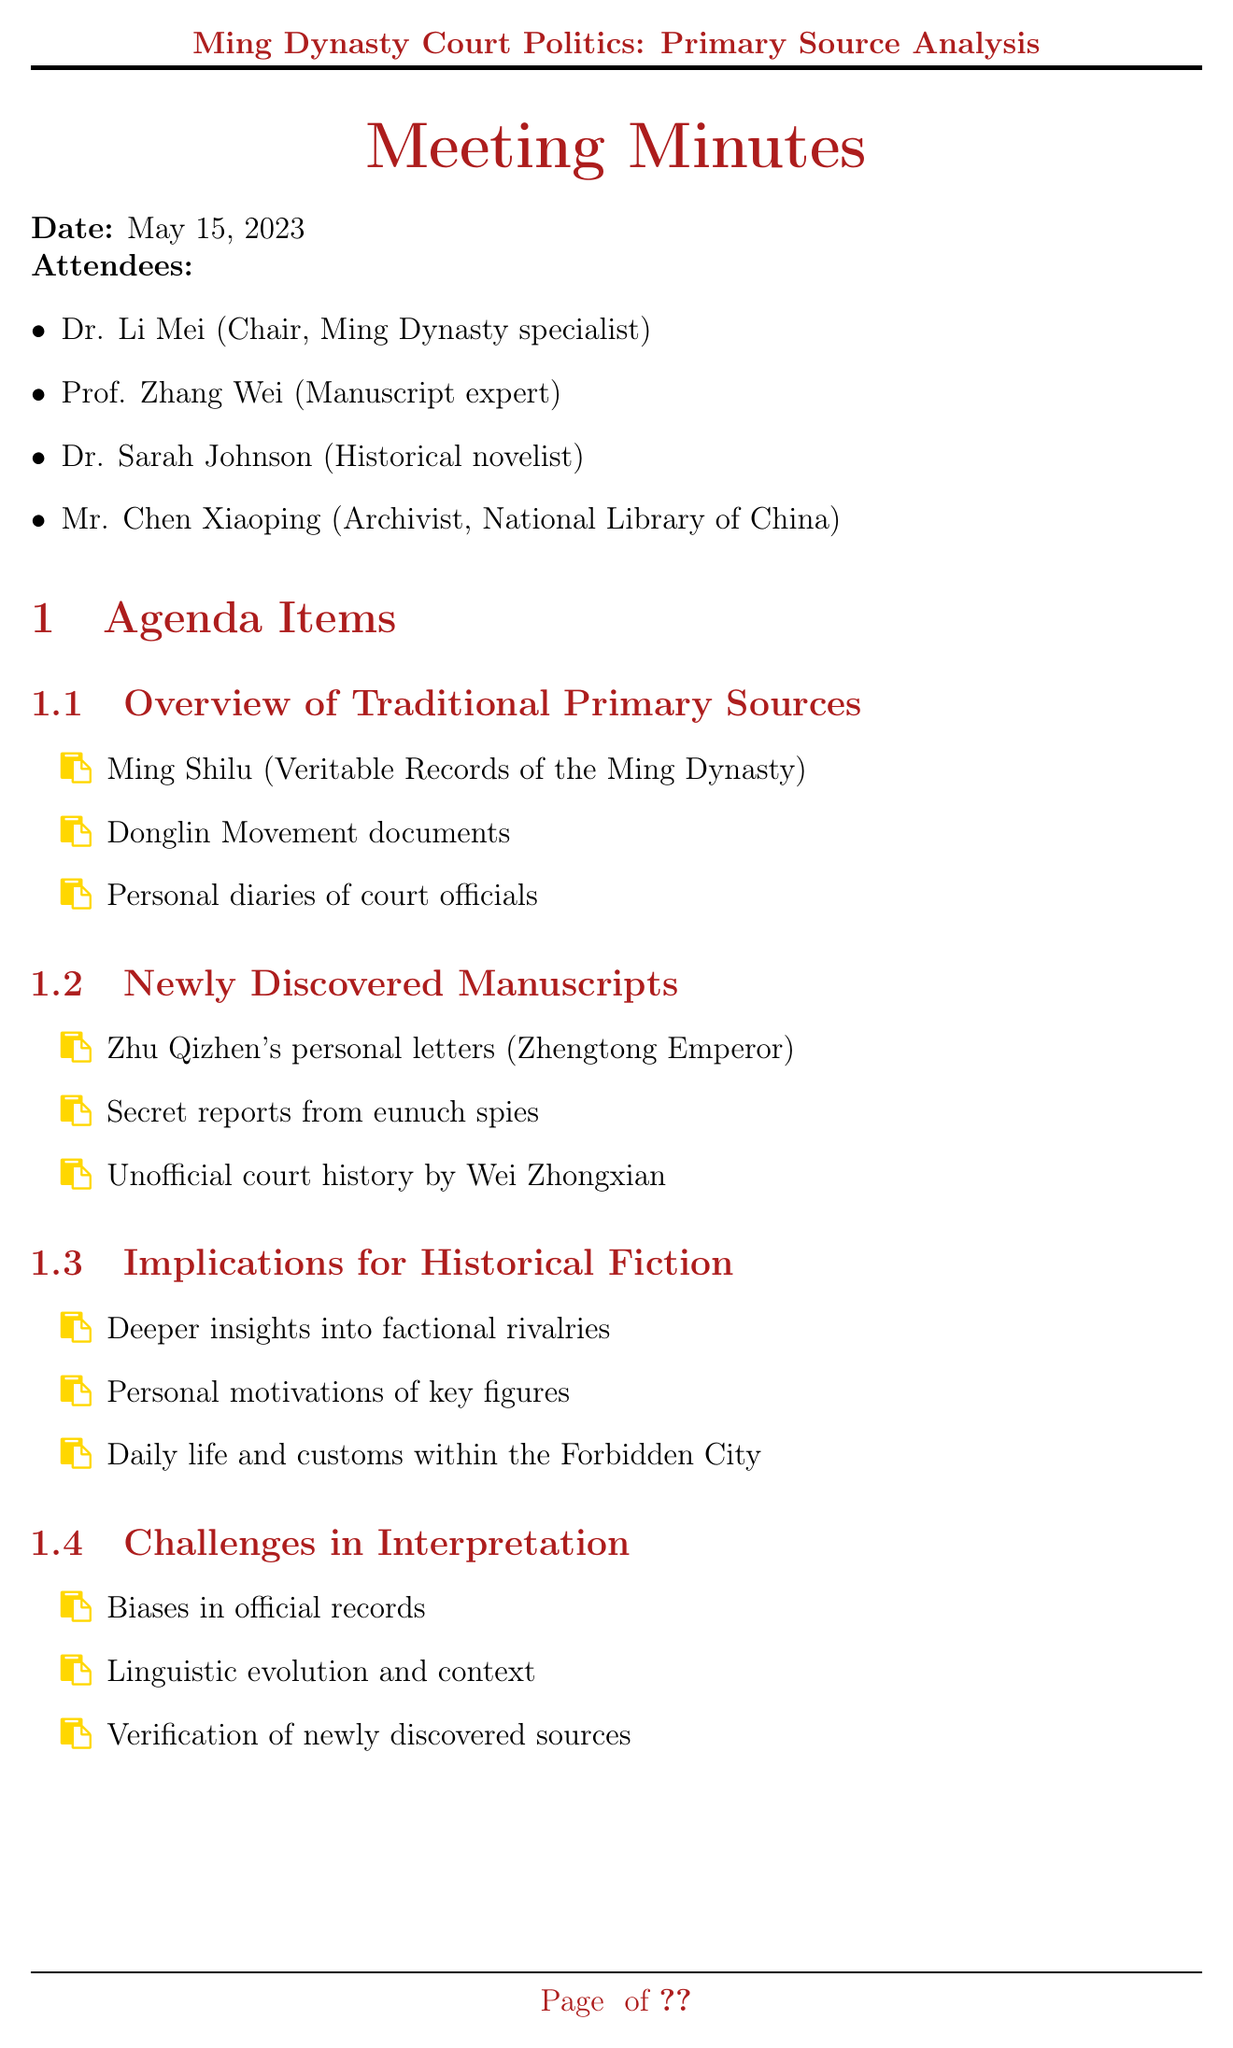What is the date of the meeting? The date of the meeting is specified in the document as May 15, 2023.
Answer: May 15, 2023 Who chaired the meeting? The document lists Dr. Li Mei as the Chair and a specialist in the Ming Dynasty.
Answer: Dr. Li Mei What is one of the newly discovered manuscripts discussed? The document mentions Zhu Qizhen's personal letters (Zhengtong Emperor) as a newly discovered manuscript.
Answer: Zhu Qizhen's personal letters What are the implications for historical fiction mentioned? The document points out that there are deeper insights into factional rivalries as an implication for historical fiction.
Answer: Deeper insights into factional rivalries What is one of the challenges in interpretation? The document highlights biases in official records as one of the challenges in interpretation.
Answer: Biases in official records How many action items were listed? The document enumerates three action items related to the meeting.
Answer: 3 What area will the future research focus on according to the minutes? The document indicates digitization of fragile manuscripts as a future research direction.
Answer: Digitization of fragile manuscripts Who is an archivist present in the meeting? The document identifies Mr. Chen Xiaoping as the archivist from the National Library of China.
Answer: Mr. Chen Xiaoping What specific workshop action item is mentioned? The document specifies organizing a workshop on deciphering Ming dynasty court language as one of the action items.
Answer: Workshop on deciphering Ming dynasty court language 